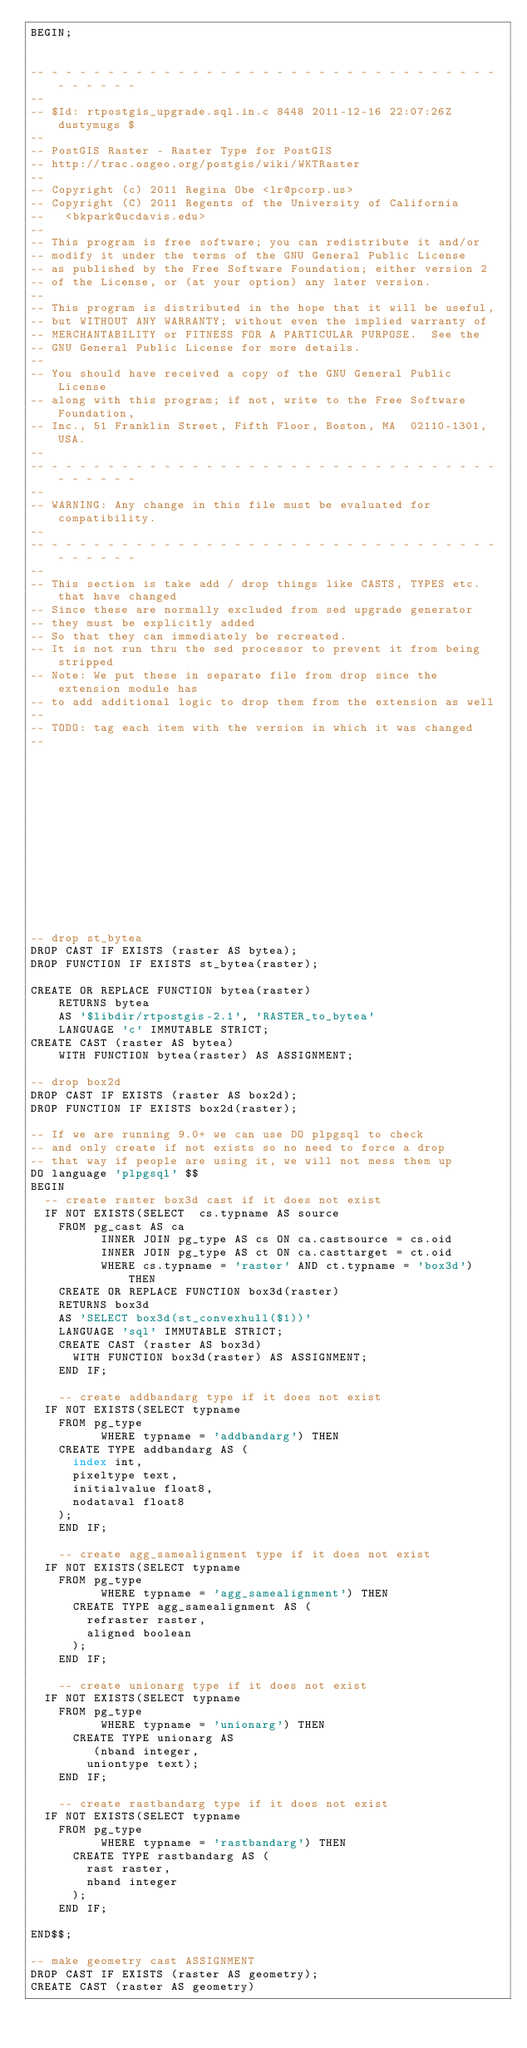Convert code to text. <code><loc_0><loc_0><loc_500><loc_500><_SQL_>BEGIN;


-- - - - - - - - - - - - - - - - - - - - - - - - - - - - - - - - - - - - - - -
--
-- $Id: rtpostgis_upgrade.sql.in.c 8448 2011-12-16 22:07:26Z dustymugs $
--
-- PostGIS Raster - Raster Type for PostGIS
-- http://trac.osgeo.org/postgis/wiki/WKTRaster
--
-- Copyright (c) 2011 Regina Obe <lr@pcorp.us>
-- Copyright (C) 2011 Regents of the University of California
--   <bkpark@ucdavis.edu>
--
-- This program is free software; you can redistribute it and/or
-- modify it under the terms of the GNU General Public License
-- as published by the Free Software Foundation; either version 2
-- of the License, or (at your option) any later version.
--
-- This program is distributed in the hope that it will be useful,
-- but WITHOUT ANY WARRANTY; without even the implied warranty of
-- MERCHANTABILITY or FITNESS FOR A PARTICULAR PURPOSE.  See the
-- GNU General Public License for more details.
--
-- You should have received a copy of the GNU General Public License
-- along with this program; if not, write to the Free Software Foundation,
-- Inc., 51 Franklin Street, Fifth Floor, Boston, MA  02110-1301, USA.
--
-- - - - - - - - - - - - - - - - - - - - - - - - - - - - - - - - - - - - - - -
--
-- WARNING: Any change in this file must be evaluated for compatibility.
--
-- - - - - - - - - - - - - - - - - - - - - - - - - - - - - - - - - - - - - - -
--
-- This section is take add / drop things like CASTS, TYPES etc. that have changed
-- Since these are normally excluded from sed upgrade generator
-- they must be explicitly added
-- So that they can immediately be recreated. 
-- It is not run thru the sed processor to prevent it from being stripped
-- Note: We put these in separate file from drop since the extension module has
-- to add additional logic to drop them from the extension as well
--
-- TODO: tag each item with the version in which it was changed
--














-- drop st_bytea
DROP CAST IF EXISTS (raster AS bytea);
DROP FUNCTION IF EXISTS st_bytea(raster);

CREATE OR REPLACE FUNCTION bytea(raster)
    RETURNS bytea
    AS '$libdir/rtpostgis-2.1', 'RASTER_to_bytea'
    LANGUAGE 'c' IMMUTABLE STRICT;
CREATE CAST (raster AS bytea)
    WITH FUNCTION bytea(raster) AS ASSIGNMENT;

-- drop box2d
DROP CAST IF EXISTS (raster AS box2d);
DROP FUNCTION IF EXISTS box2d(raster);

-- If we are running 9.0+ we can use DO plpgsql to check
-- and only create if not exists so no need to force a drop
-- that way if people are using it, we will not mess them up
DO language 'plpgsql' $$
BEGIN
	-- create raster box3d cast if it does not exist
	IF NOT EXISTS(SELECT  cs.typname AS source
		FROM pg_cast AS ca 
        	INNER JOIN pg_type AS cs ON ca.castsource = cs.oid
        	INNER JOIN pg_type AS ct ON ca.casttarget = ct.oid
        	WHERE cs.typname = 'raster' AND ct.typname = 'box3d') THEN
		CREATE OR REPLACE FUNCTION box3d(raster)
		RETURNS box3d
		AS 'SELECT box3d(st_convexhull($1))'
		LANGUAGE 'sql' IMMUTABLE STRICT;
		CREATE CAST (raster AS box3d)
			WITH FUNCTION box3d(raster) AS ASSIGNMENT;
    END IF;
    
    -- create addbandarg type if it does not exist
	IF NOT EXISTS(SELECT typname
		FROM pg_type 
        	WHERE typname = 'addbandarg') THEN
		CREATE TYPE addbandarg AS (
			index int,
			pixeltype text,
			initialvalue float8,
			nodataval float8
		);
    END IF;
    
    -- create agg_samealignment type if it does not exist
	IF NOT EXISTS(SELECT typname 
		FROM pg_type 
        	WHERE typname = 'agg_samealignment') THEN
			CREATE TYPE agg_samealignment AS (
				refraster raster,
				aligned boolean
			);
    END IF;
    
    -- create unionarg type if it does not exist
	IF NOT EXISTS(SELECT typname
		FROM pg_type 
        	WHERE typname = 'unionarg') THEN
			CREATE TYPE unionarg AS
			   (nband integer,
				uniontype text);
    END IF;

    -- create rastbandarg type if it does not exist
	IF NOT EXISTS(SELECT typname
		FROM pg_type 
        	WHERE typname = 'rastbandarg') THEN
			CREATE TYPE rastbandarg AS (
				rast raster,
				nband integer
			);
    END IF;

END$$;	

-- make geometry cast ASSIGNMENT
DROP CAST IF EXISTS (raster AS geometry);
CREATE CAST (raster AS geometry)</code> 